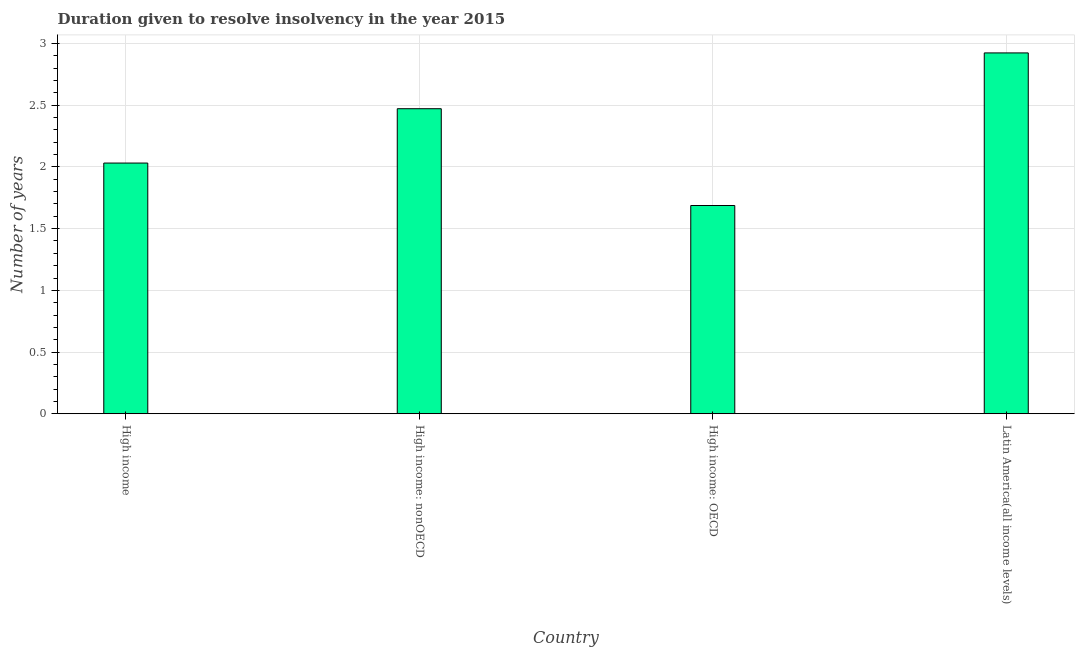Does the graph contain any zero values?
Make the answer very short. No. Does the graph contain grids?
Keep it short and to the point. Yes. What is the title of the graph?
Give a very brief answer. Duration given to resolve insolvency in the year 2015. What is the label or title of the X-axis?
Offer a very short reply. Country. What is the label or title of the Y-axis?
Provide a succinct answer. Number of years. What is the number of years to resolve insolvency in Latin America(all income levels)?
Ensure brevity in your answer.  2.92. Across all countries, what is the maximum number of years to resolve insolvency?
Your answer should be compact. 2.92. Across all countries, what is the minimum number of years to resolve insolvency?
Provide a succinct answer. 1.69. In which country was the number of years to resolve insolvency maximum?
Your response must be concise. Latin America(all income levels). In which country was the number of years to resolve insolvency minimum?
Keep it short and to the point. High income: OECD. What is the sum of the number of years to resolve insolvency?
Your response must be concise. 9.12. What is the difference between the number of years to resolve insolvency in High income and High income: OECD?
Offer a very short reply. 0.34. What is the average number of years to resolve insolvency per country?
Your response must be concise. 2.28. What is the median number of years to resolve insolvency?
Give a very brief answer. 2.25. In how many countries, is the number of years to resolve insolvency greater than 2.3 ?
Your answer should be very brief. 2. What is the ratio of the number of years to resolve insolvency in High income: OECD to that in Latin America(all income levels)?
Offer a terse response. 0.58. Is the number of years to resolve insolvency in High income less than that in Latin America(all income levels)?
Your answer should be compact. Yes. What is the difference between the highest and the second highest number of years to resolve insolvency?
Your answer should be compact. 0.45. What is the difference between the highest and the lowest number of years to resolve insolvency?
Keep it short and to the point. 1.24. In how many countries, is the number of years to resolve insolvency greater than the average number of years to resolve insolvency taken over all countries?
Your answer should be compact. 2. Are the values on the major ticks of Y-axis written in scientific E-notation?
Offer a very short reply. No. What is the Number of years of High income?
Make the answer very short. 2.03. What is the Number of years of High income: nonOECD?
Offer a very short reply. 2.47. What is the Number of years in High income: OECD?
Give a very brief answer. 1.69. What is the Number of years of Latin America(all income levels)?
Ensure brevity in your answer.  2.92. What is the difference between the Number of years in High income and High income: nonOECD?
Ensure brevity in your answer.  -0.44. What is the difference between the Number of years in High income and High income: OECD?
Keep it short and to the point. 0.34. What is the difference between the Number of years in High income and Latin America(all income levels)?
Ensure brevity in your answer.  -0.89. What is the difference between the Number of years in High income: nonOECD and High income: OECD?
Offer a very short reply. 0.78. What is the difference between the Number of years in High income: nonOECD and Latin America(all income levels)?
Your response must be concise. -0.45. What is the difference between the Number of years in High income: OECD and Latin America(all income levels)?
Your answer should be very brief. -1.24. What is the ratio of the Number of years in High income to that in High income: nonOECD?
Your response must be concise. 0.82. What is the ratio of the Number of years in High income to that in High income: OECD?
Ensure brevity in your answer.  1.2. What is the ratio of the Number of years in High income to that in Latin America(all income levels)?
Provide a short and direct response. 0.69. What is the ratio of the Number of years in High income: nonOECD to that in High income: OECD?
Give a very brief answer. 1.47. What is the ratio of the Number of years in High income: nonOECD to that in Latin America(all income levels)?
Ensure brevity in your answer.  0.84. What is the ratio of the Number of years in High income: OECD to that in Latin America(all income levels)?
Your answer should be compact. 0.58. 